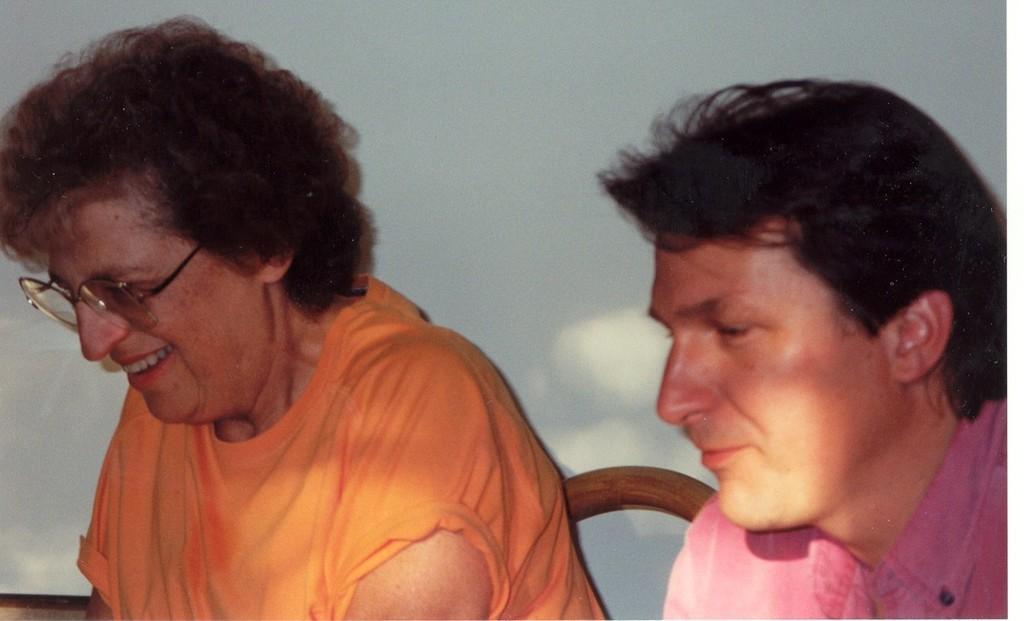Please provide a concise description of this image. In this image we can see there are two persons sitting on the chairs, one of them is smiling, behind them there is a wall. 